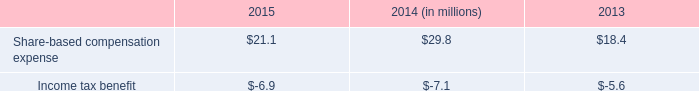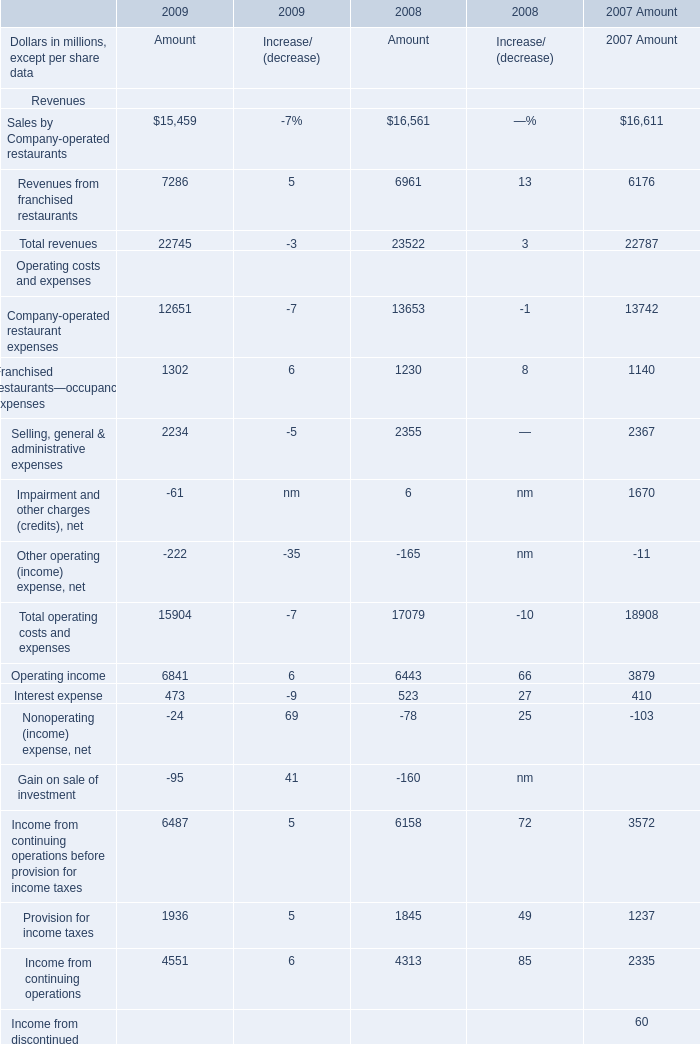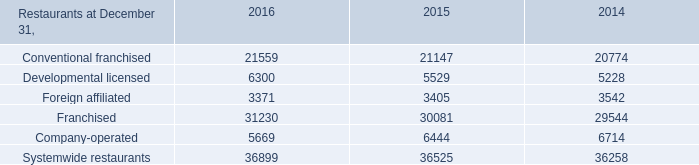What's the average of Systemwide restaurants of 2014, and Operating income Operating costs and expenses of 2009 Amount ? 
Computations: ((36258.0 + 6841.0) / 2)
Answer: 21549.5. 